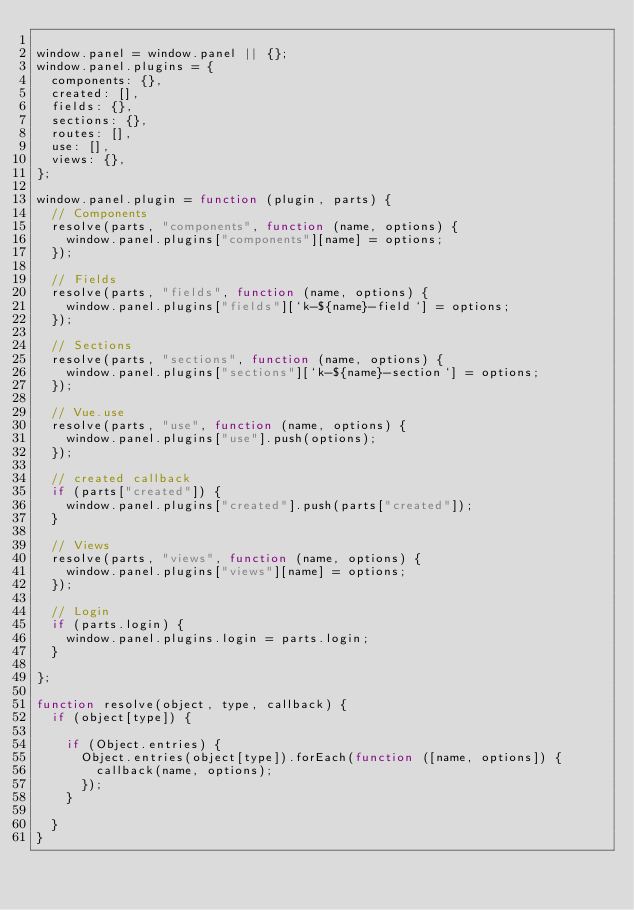Convert code to text. <code><loc_0><loc_0><loc_500><loc_500><_JavaScript_>
window.panel = window.panel || {};
window.panel.plugins = {
  components: {},
  created: [],
  fields: {},
  sections: {},
  routes: [],
  use: [],
  views: {},
};

window.panel.plugin = function (plugin, parts) {
  // Components
  resolve(parts, "components", function (name, options) {
    window.panel.plugins["components"][name] = options;
  });

  // Fields
  resolve(parts, "fields", function (name, options) {
    window.panel.plugins["fields"][`k-${name}-field`] = options;
  });

  // Sections
  resolve(parts, "sections", function (name, options) {
    window.panel.plugins["sections"][`k-${name}-section`] = options;
  });

  // Vue.use
  resolve(parts, "use", function (name, options) {
    window.panel.plugins["use"].push(options);
  });

  // created callback
  if (parts["created"]) {
    window.panel.plugins["created"].push(parts["created"]);
  }

  // Views
  resolve(parts, "views", function (name, options) {
    window.panel.plugins["views"][name] = options;
  });

  // Login
  if (parts.login) {
    window.panel.plugins.login = parts.login;
  }

};

function resolve(object, type, callback) {
  if (object[type]) {

    if (Object.entries) {
      Object.entries(object[type]).forEach(function ([name, options]) {
        callback(name, options);
      });
    }

  }
}
</code> 